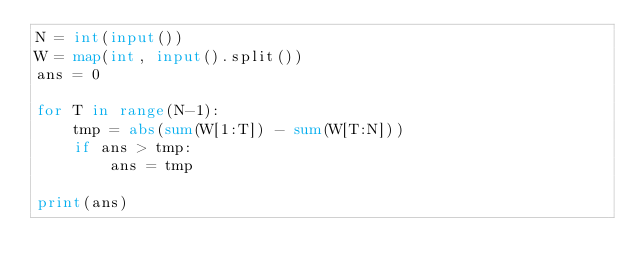Convert code to text. <code><loc_0><loc_0><loc_500><loc_500><_Python_>N = int(input())
W = map(int, input().split())
ans = 0

for T in range(N-1):
    tmp = abs(sum(W[1:T]) - sum(W[T:N]))
    if ans > tmp:
        ans = tmp
 
print(ans)</code> 